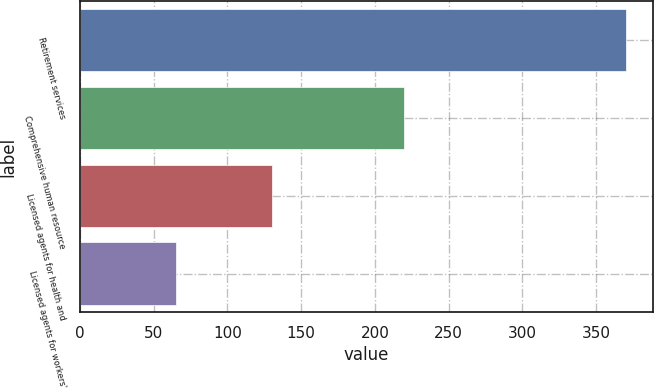<chart> <loc_0><loc_0><loc_500><loc_500><bar_chart><fcel>Retirement services<fcel>Comprehensive human resource<fcel>Licensed agents for health and<fcel>Licensed agents for workers'<nl><fcel>370<fcel>220<fcel>130<fcel>65<nl></chart> 